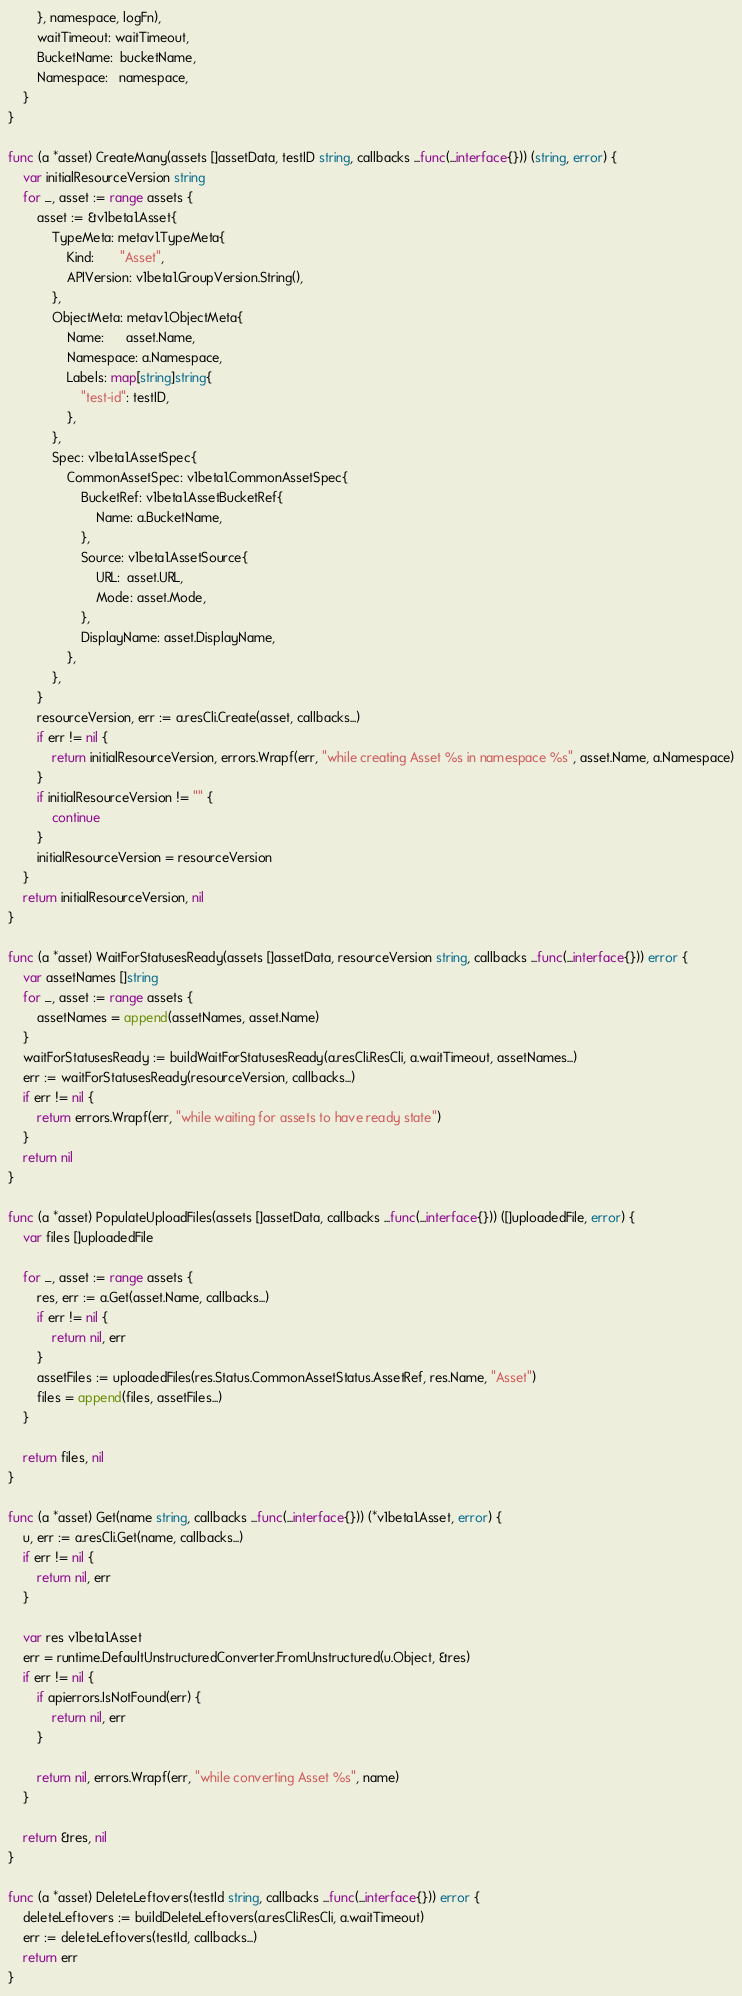<code> <loc_0><loc_0><loc_500><loc_500><_Go_>		}, namespace, logFn),
		waitTimeout: waitTimeout,
		BucketName:  bucketName,
		Namespace:   namespace,
	}
}

func (a *asset) CreateMany(assets []assetData, testID string, callbacks ...func(...interface{})) (string, error) {
	var initialResourceVersion string
	for _, asset := range assets {
		asset := &v1beta1.Asset{
			TypeMeta: metav1.TypeMeta{
				Kind:       "Asset",
				APIVersion: v1beta1.GroupVersion.String(),
			},
			ObjectMeta: metav1.ObjectMeta{
				Name:      asset.Name,
				Namespace: a.Namespace,
				Labels: map[string]string{
					"test-id": testID,
				},
			},
			Spec: v1beta1.AssetSpec{
				CommonAssetSpec: v1beta1.CommonAssetSpec{
					BucketRef: v1beta1.AssetBucketRef{
						Name: a.BucketName,
					},
					Source: v1beta1.AssetSource{
						URL:  asset.URL,
						Mode: asset.Mode,
					},
					DisplayName: asset.DisplayName,
				},
			},
		}
		resourceVersion, err := a.resCli.Create(asset, callbacks...)
		if err != nil {
			return initialResourceVersion, errors.Wrapf(err, "while creating Asset %s in namespace %s", asset.Name, a.Namespace)
		}
		if initialResourceVersion != "" {
			continue
		}
		initialResourceVersion = resourceVersion
	}
	return initialResourceVersion, nil
}

func (a *asset) WaitForStatusesReady(assets []assetData, resourceVersion string, callbacks ...func(...interface{})) error {
	var assetNames []string
	for _, asset := range assets {
		assetNames = append(assetNames, asset.Name)
	}
	waitForStatusesReady := buildWaitForStatusesReady(a.resCli.ResCli, a.waitTimeout, assetNames...)
	err := waitForStatusesReady(resourceVersion, callbacks...)
	if err != nil {
		return errors.Wrapf(err, "while waiting for assets to have ready state")
	}
	return nil
}

func (a *asset) PopulateUploadFiles(assets []assetData, callbacks ...func(...interface{})) ([]uploadedFile, error) {
	var files []uploadedFile

	for _, asset := range assets {
		res, err := a.Get(asset.Name, callbacks...)
		if err != nil {
			return nil, err
		}
		assetFiles := uploadedFiles(res.Status.CommonAssetStatus.AssetRef, res.Name, "Asset")
		files = append(files, assetFiles...)
	}

	return files, nil
}

func (a *asset) Get(name string, callbacks ...func(...interface{})) (*v1beta1.Asset, error) {
	u, err := a.resCli.Get(name, callbacks...)
	if err != nil {
		return nil, err
	}

	var res v1beta1.Asset
	err = runtime.DefaultUnstructuredConverter.FromUnstructured(u.Object, &res)
	if err != nil {
		if apierrors.IsNotFound(err) {
			return nil, err
		}

		return nil, errors.Wrapf(err, "while converting Asset %s", name)
	}

	return &res, nil
}

func (a *asset) DeleteLeftovers(testId string, callbacks ...func(...interface{})) error {
	deleteLeftovers := buildDeleteLeftovers(a.resCli.ResCli, a.waitTimeout)
	err := deleteLeftovers(testId, callbacks...)
	return err
}
</code> 